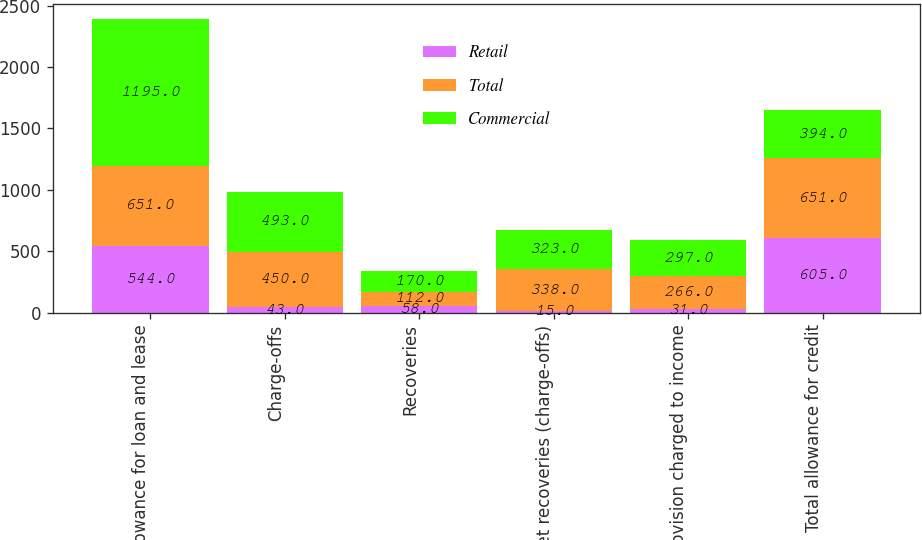Convert chart. <chart><loc_0><loc_0><loc_500><loc_500><stacked_bar_chart><ecel><fcel>Allowance for loan and lease<fcel>Charge-offs<fcel>Recoveries<fcel>Net recoveries (charge-offs)<fcel>Provision charged to income<fcel>Total allowance for credit<nl><fcel>Retail<fcel>544<fcel>43<fcel>58<fcel>15<fcel>31<fcel>605<nl><fcel>Total<fcel>651<fcel>450<fcel>112<fcel>338<fcel>266<fcel>651<nl><fcel>Commercial<fcel>1195<fcel>493<fcel>170<fcel>323<fcel>297<fcel>394<nl></chart> 